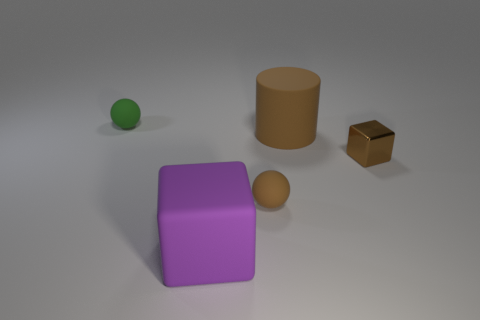Is the small block the same color as the cylinder?
Provide a succinct answer. Yes. The big rubber thing to the right of the large matte thing that is in front of the brown shiny thing is what shape?
Provide a short and direct response. Cylinder. There is a small green object that is the same material as the big block; what shape is it?
Your answer should be compact. Sphere. How many other things are there of the same shape as the tiny green rubber object?
Provide a succinct answer. 1. There is a green rubber object that is to the left of the purple cube; is its size the same as the big block?
Your answer should be compact. No. Is the number of brown cubes that are in front of the small metallic cube greater than the number of brown matte things?
Your answer should be very brief. No. There is a rubber ball in front of the green rubber sphere; what number of tiny rubber things are behind it?
Your response must be concise. 1. Is the number of small brown matte balls to the right of the big brown cylinder less than the number of brown matte balls?
Provide a short and direct response. Yes. There is a matte ball that is in front of the object that is on the left side of the purple matte thing; is there a purple thing on the right side of it?
Offer a terse response. No. Does the purple block have the same material as the thing that is behind the brown cylinder?
Keep it short and to the point. Yes. 